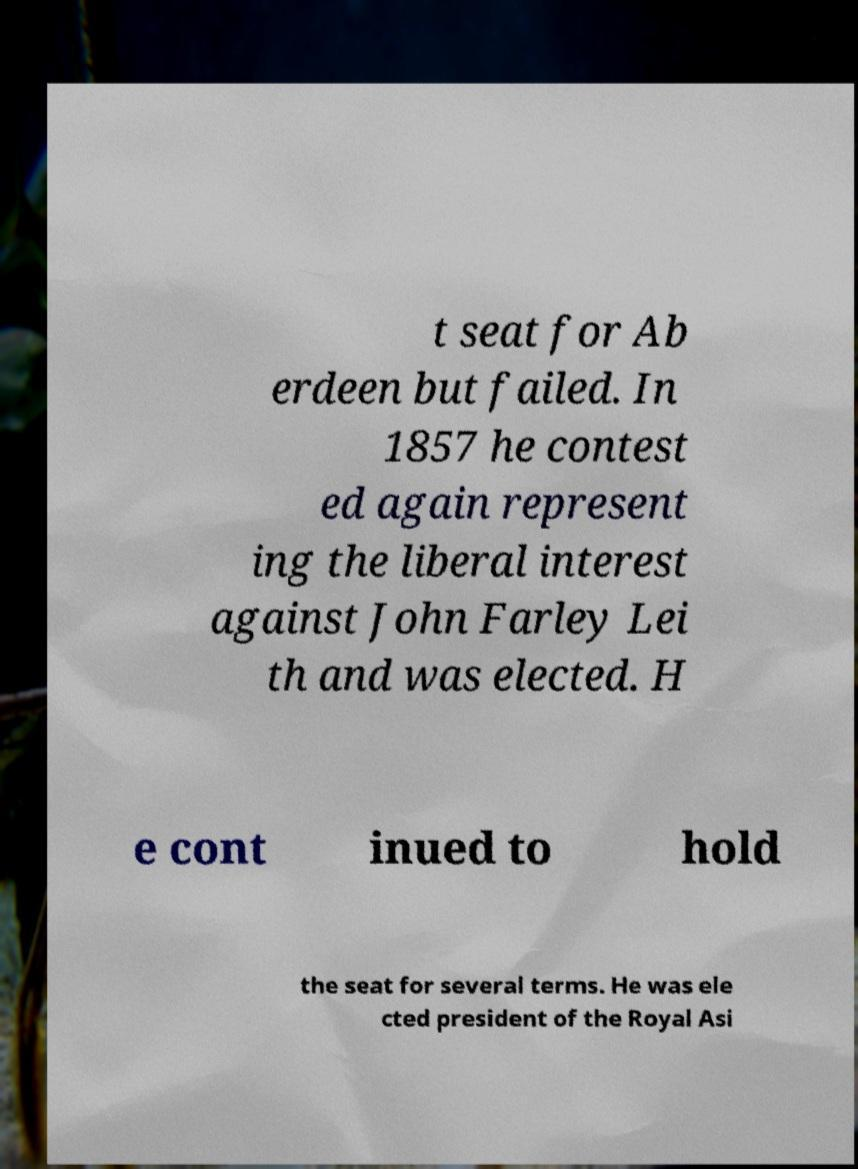Can you read and provide the text displayed in the image?This photo seems to have some interesting text. Can you extract and type it out for me? t seat for Ab erdeen but failed. In 1857 he contest ed again represent ing the liberal interest against John Farley Lei th and was elected. H e cont inued to hold the seat for several terms. He was ele cted president of the Royal Asi 